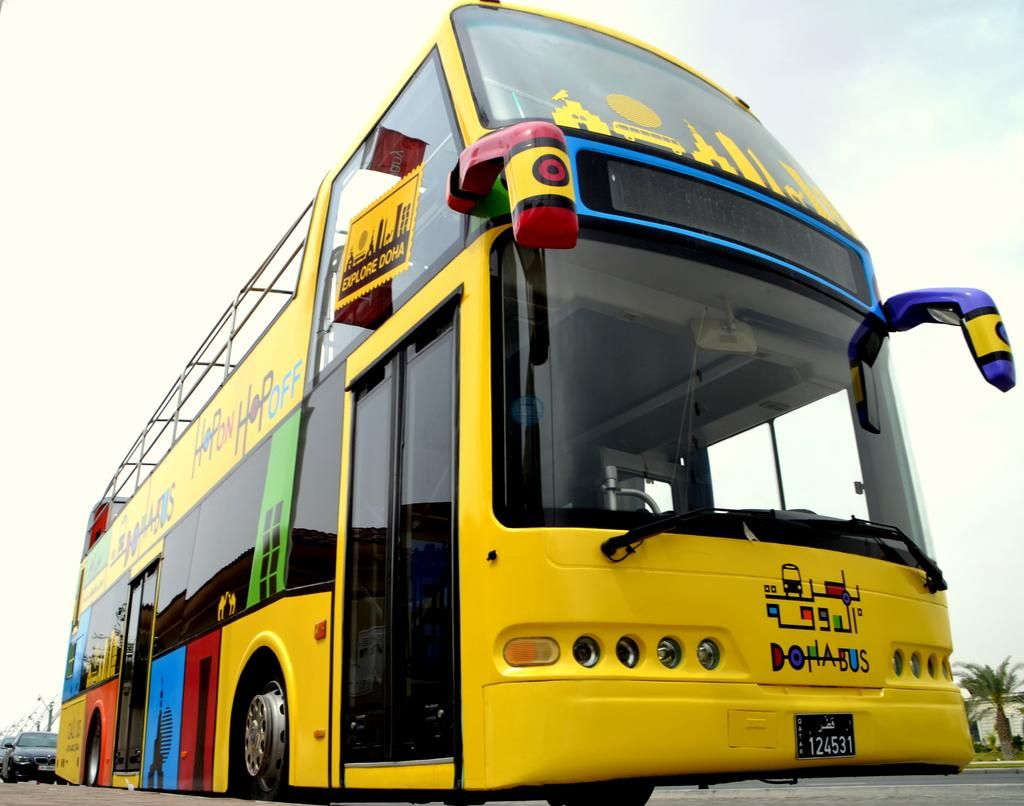What type of vehicle is in the image? There is a Double-decker bus in the image. What other type of vehicle can be seen in the image? There is a car on the road in the image. What natural element is present at the bottom right side of the image? There is a tree at the bottom right side of the image. What can be seen in the background of the image? The sky is visible in the background of the image. What type of furniture is visible in the image? There is no furniture present in the image; it features a Double-decker bus, a car, a tree, and the sky. 